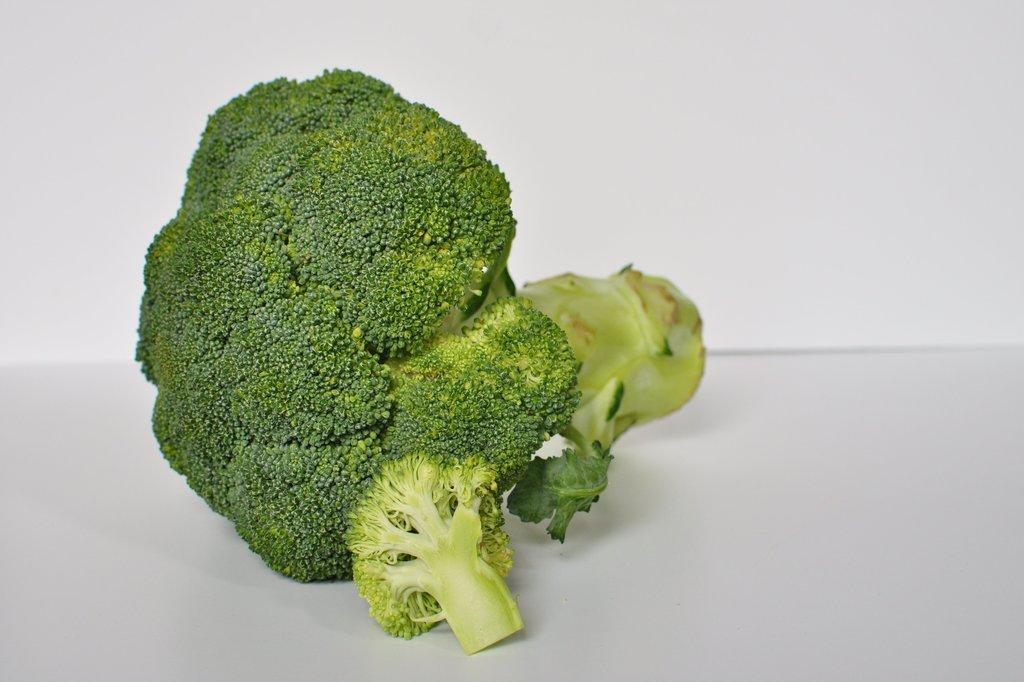What type of vegetable is present in the image? There is broccoli in the image. What color is the broccoli? The broccoli is green in color. What is the color of the background in the image? The background of the image is white. Where is the family shopping for broccoli in the image? There is no family or shopping depicted in the image; it only shows broccoli on a white background. What type of architectural feature can be seen in the image? There are no architectural features present in the image; it only shows broccoli on a white background. 